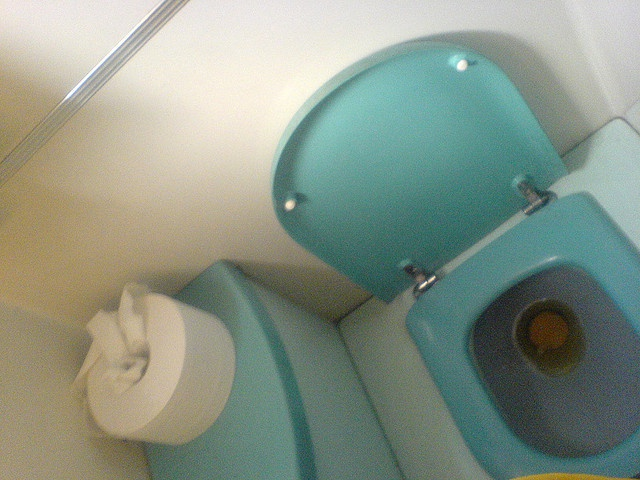Describe the objects in this image and their specific colors. I can see a toilet in lightgray, teal, and black tones in this image. 